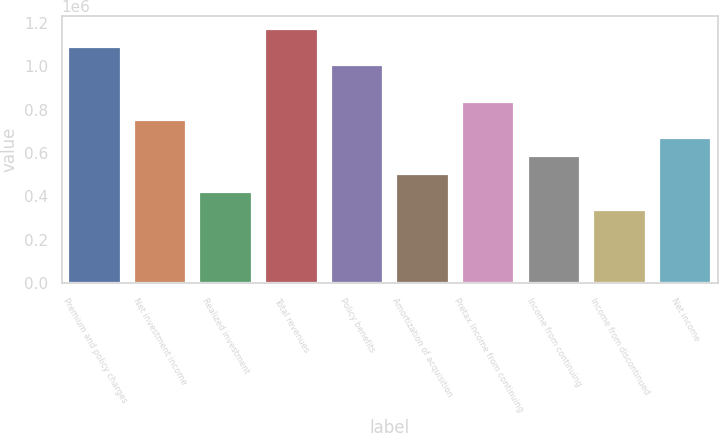<chart> <loc_0><loc_0><loc_500><loc_500><bar_chart><fcel>Premium and policy charges<fcel>Net investment income<fcel>Realized investment<fcel>Total revenues<fcel>Policy benefits<fcel>Amortization of acquisition<fcel>Pretax Income from continuing<fcel>Income from continuing<fcel>Income from discontinued<fcel>Net income<nl><fcel>1.08841e+06<fcel>753517<fcel>418621<fcel>1.17214e+06<fcel>1.00469e+06<fcel>502345<fcel>837241<fcel>586069<fcel>334897<fcel>669793<nl></chart> 